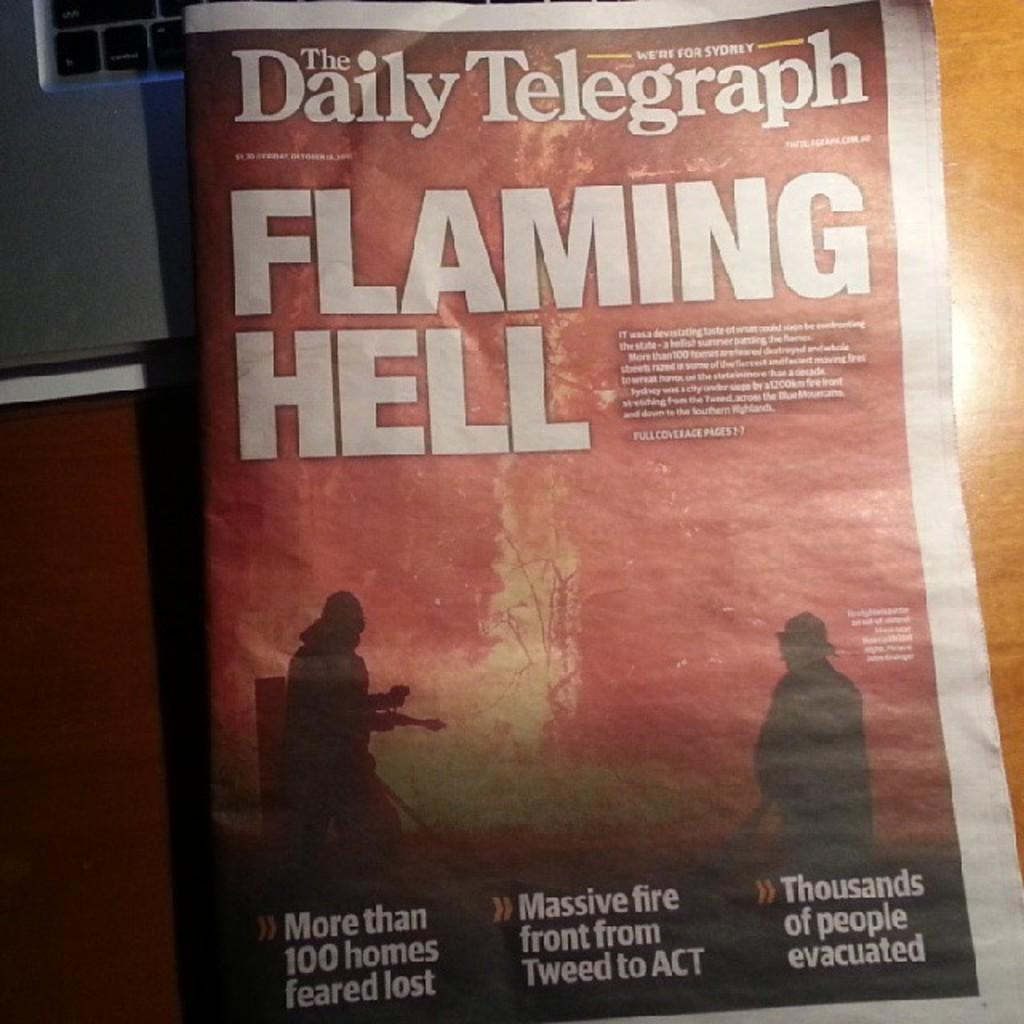<image>
Give a short and clear explanation of the subsequent image. The front page of a tabloid newspaper depicting a fire with the headline FLAMING HELL. 